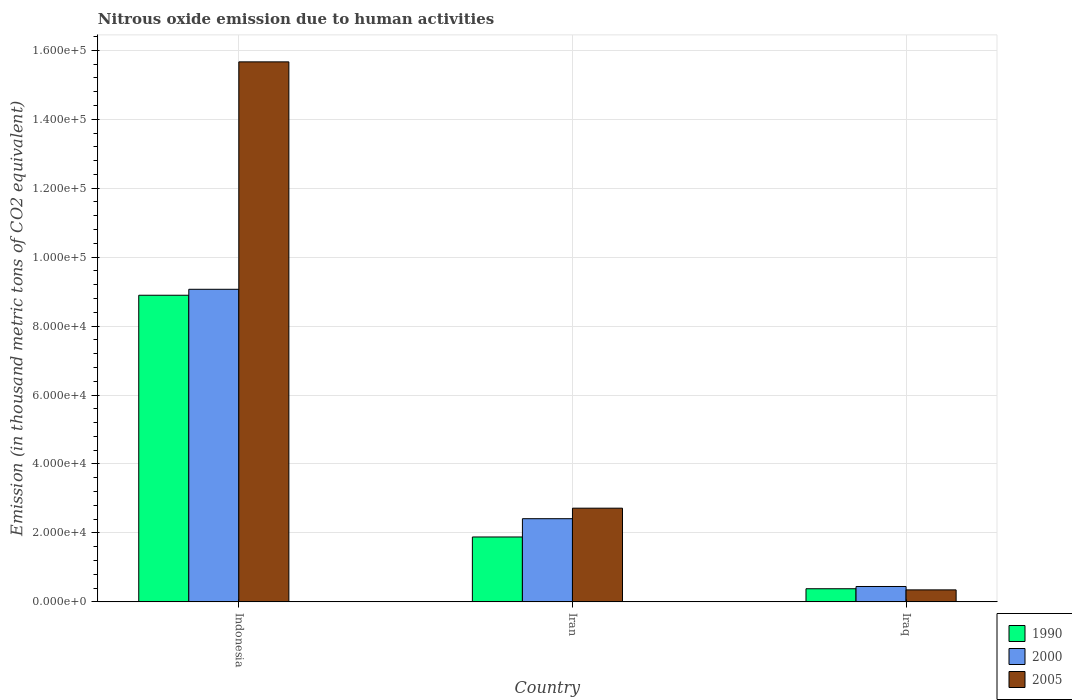Are the number of bars per tick equal to the number of legend labels?
Offer a terse response. Yes. How many bars are there on the 1st tick from the left?
Make the answer very short. 3. What is the label of the 3rd group of bars from the left?
Provide a short and direct response. Iraq. In how many cases, is the number of bars for a given country not equal to the number of legend labels?
Provide a succinct answer. 0. What is the amount of nitrous oxide emitted in 2005 in Indonesia?
Make the answer very short. 1.57e+05. Across all countries, what is the maximum amount of nitrous oxide emitted in 1990?
Your response must be concise. 8.89e+04. Across all countries, what is the minimum amount of nitrous oxide emitted in 2005?
Keep it short and to the point. 3478.3. In which country was the amount of nitrous oxide emitted in 2000 maximum?
Offer a terse response. Indonesia. In which country was the amount of nitrous oxide emitted in 1990 minimum?
Your answer should be very brief. Iraq. What is the total amount of nitrous oxide emitted in 2005 in the graph?
Provide a succinct answer. 1.87e+05. What is the difference between the amount of nitrous oxide emitted in 1990 in Indonesia and that in Iraq?
Make the answer very short. 8.51e+04. What is the difference between the amount of nitrous oxide emitted in 2005 in Iraq and the amount of nitrous oxide emitted in 2000 in Indonesia?
Ensure brevity in your answer.  -8.72e+04. What is the average amount of nitrous oxide emitted in 2000 per country?
Ensure brevity in your answer.  3.98e+04. What is the difference between the amount of nitrous oxide emitted of/in 2005 and amount of nitrous oxide emitted of/in 2000 in Iraq?
Offer a terse response. -984. In how many countries, is the amount of nitrous oxide emitted in 2000 greater than 32000 thousand metric tons?
Your answer should be compact. 1. What is the ratio of the amount of nitrous oxide emitted in 2005 in Indonesia to that in Iraq?
Keep it short and to the point. 45.04. Is the amount of nitrous oxide emitted in 2005 in Indonesia less than that in Iran?
Give a very brief answer. No. What is the difference between the highest and the second highest amount of nitrous oxide emitted in 2005?
Make the answer very short. -1.29e+05. What is the difference between the highest and the lowest amount of nitrous oxide emitted in 2000?
Give a very brief answer. 8.62e+04. Is the sum of the amount of nitrous oxide emitted in 1990 in Indonesia and Iraq greater than the maximum amount of nitrous oxide emitted in 2000 across all countries?
Your answer should be very brief. Yes. What does the 3rd bar from the left in Iraq represents?
Give a very brief answer. 2005. What does the 2nd bar from the right in Iraq represents?
Provide a short and direct response. 2000. Is it the case that in every country, the sum of the amount of nitrous oxide emitted in 1990 and amount of nitrous oxide emitted in 2005 is greater than the amount of nitrous oxide emitted in 2000?
Ensure brevity in your answer.  Yes. How many bars are there?
Your response must be concise. 9. How many countries are there in the graph?
Offer a terse response. 3. Are the values on the major ticks of Y-axis written in scientific E-notation?
Ensure brevity in your answer.  Yes. Does the graph contain any zero values?
Make the answer very short. No. Where does the legend appear in the graph?
Keep it short and to the point. Bottom right. How many legend labels are there?
Keep it short and to the point. 3. What is the title of the graph?
Offer a very short reply. Nitrous oxide emission due to human activities. Does "1979" appear as one of the legend labels in the graph?
Ensure brevity in your answer.  No. What is the label or title of the Y-axis?
Your answer should be compact. Emission (in thousand metric tons of CO2 equivalent). What is the Emission (in thousand metric tons of CO2 equivalent) of 1990 in Indonesia?
Offer a very short reply. 8.89e+04. What is the Emission (in thousand metric tons of CO2 equivalent) in 2000 in Indonesia?
Your response must be concise. 9.07e+04. What is the Emission (in thousand metric tons of CO2 equivalent) of 2005 in Indonesia?
Your answer should be compact. 1.57e+05. What is the Emission (in thousand metric tons of CO2 equivalent) in 1990 in Iran?
Your answer should be compact. 1.88e+04. What is the Emission (in thousand metric tons of CO2 equivalent) in 2000 in Iran?
Give a very brief answer. 2.41e+04. What is the Emission (in thousand metric tons of CO2 equivalent) in 2005 in Iran?
Provide a short and direct response. 2.72e+04. What is the Emission (in thousand metric tons of CO2 equivalent) of 1990 in Iraq?
Offer a very short reply. 3808.9. What is the Emission (in thousand metric tons of CO2 equivalent) in 2000 in Iraq?
Give a very brief answer. 4462.3. What is the Emission (in thousand metric tons of CO2 equivalent) of 2005 in Iraq?
Give a very brief answer. 3478.3. Across all countries, what is the maximum Emission (in thousand metric tons of CO2 equivalent) in 1990?
Offer a terse response. 8.89e+04. Across all countries, what is the maximum Emission (in thousand metric tons of CO2 equivalent) in 2000?
Provide a succinct answer. 9.07e+04. Across all countries, what is the maximum Emission (in thousand metric tons of CO2 equivalent) of 2005?
Ensure brevity in your answer.  1.57e+05. Across all countries, what is the minimum Emission (in thousand metric tons of CO2 equivalent) of 1990?
Your answer should be compact. 3808.9. Across all countries, what is the minimum Emission (in thousand metric tons of CO2 equivalent) in 2000?
Offer a very short reply. 4462.3. Across all countries, what is the minimum Emission (in thousand metric tons of CO2 equivalent) of 2005?
Make the answer very short. 3478.3. What is the total Emission (in thousand metric tons of CO2 equivalent) of 1990 in the graph?
Your answer should be very brief. 1.12e+05. What is the total Emission (in thousand metric tons of CO2 equivalent) of 2000 in the graph?
Offer a terse response. 1.19e+05. What is the total Emission (in thousand metric tons of CO2 equivalent) in 2005 in the graph?
Provide a short and direct response. 1.87e+05. What is the difference between the Emission (in thousand metric tons of CO2 equivalent) of 1990 in Indonesia and that in Iran?
Your response must be concise. 7.01e+04. What is the difference between the Emission (in thousand metric tons of CO2 equivalent) in 2000 in Indonesia and that in Iran?
Give a very brief answer. 6.65e+04. What is the difference between the Emission (in thousand metric tons of CO2 equivalent) in 2005 in Indonesia and that in Iran?
Your answer should be compact. 1.29e+05. What is the difference between the Emission (in thousand metric tons of CO2 equivalent) in 1990 in Indonesia and that in Iraq?
Keep it short and to the point. 8.51e+04. What is the difference between the Emission (in thousand metric tons of CO2 equivalent) in 2000 in Indonesia and that in Iraq?
Your answer should be compact. 8.62e+04. What is the difference between the Emission (in thousand metric tons of CO2 equivalent) of 2005 in Indonesia and that in Iraq?
Provide a short and direct response. 1.53e+05. What is the difference between the Emission (in thousand metric tons of CO2 equivalent) of 1990 in Iran and that in Iraq?
Your response must be concise. 1.50e+04. What is the difference between the Emission (in thousand metric tons of CO2 equivalent) in 2000 in Iran and that in Iraq?
Your response must be concise. 1.97e+04. What is the difference between the Emission (in thousand metric tons of CO2 equivalent) in 2005 in Iran and that in Iraq?
Make the answer very short. 2.37e+04. What is the difference between the Emission (in thousand metric tons of CO2 equivalent) of 1990 in Indonesia and the Emission (in thousand metric tons of CO2 equivalent) of 2000 in Iran?
Make the answer very short. 6.48e+04. What is the difference between the Emission (in thousand metric tons of CO2 equivalent) of 1990 in Indonesia and the Emission (in thousand metric tons of CO2 equivalent) of 2005 in Iran?
Offer a very short reply. 6.18e+04. What is the difference between the Emission (in thousand metric tons of CO2 equivalent) of 2000 in Indonesia and the Emission (in thousand metric tons of CO2 equivalent) of 2005 in Iran?
Keep it short and to the point. 6.35e+04. What is the difference between the Emission (in thousand metric tons of CO2 equivalent) in 1990 in Indonesia and the Emission (in thousand metric tons of CO2 equivalent) in 2000 in Iraq?
Ensure brevity in your answer.  8.45e+04. What is the difference between the Emission (in thousand metric tons of CO2 equivalent) of 1990 in Indonesia and the Emission (in thousand metric tons of CO2 equivalent) of 2005 in Iraq?
Provide a short and direct response. 8.55e+04. What is the difference between the Emission (in thousand metric tons of CO2 equivalent) in 2000 in Indonesia and the Emission (in thousand metric tons of CO2 equivalent) in 2005 in Iraq?
Your response must be concise. 8.72e+04. What is the difference between the Emission (in thousand metric tons of CO2 equivalent) in 1990 in Iran and the Emission (in thousand metric tons of CO2 equivalent) in 2000 in Iraq?
Provide a succinct answer. 1.44e+04. What is the difference between the Emission (in thousand metric tons of CO2 equivalent) of 1990 in Iran and the Emission (in thousand metric tons of CO2 equivalent) of 2005 in Iraq?
Provide a short and direct response. 1.53e+04. What is the difference between the Emission (in thousand metric tons of CO2 equivalent) of 2000 in Iran and the Emission (in thousand metric tons of CO2 equivalent) of 2005 in Iraq?
Offer a very short reply. 2.06e+04. What is the average Emission (in thousand metric tons of CO2 equivalent) of 1990 per country?
Ensure brevity in your answer.  3.72e+04. What is the average Emission (in thousand metric tons of CO2 equivalent) in 2000 per country?
Provide a short and direct response. 3.98e+04. What is the average Emission (in thousand metric tons of CO2 equivalent) in 2005 per country?
Give a very brief answer. 6.24e+04. What is the difference between the Emission (in thousand metric tons of CO2 equivalent) of 1990 and Emission (in thousand metric tons of CO2 equivalent) of 2000 in Indonesia?
Your answer should be compact. -1727.1. What is the difference between the Emission (in thousand metric tons of CO2 equivalent) of 1990 and Emission (in thousand metric tons of CO2 equivalent) of 2005 in Indonesia?
Provide a short and direct response. -6.77e+04. What is the difference between the Emission (in thousand metric tons of CO2 equivalent) in 2000 and Emission (in thousand metric tons of CO2 equivalent) in 2005 in Indonesia?
Give a very brief answer. -6.60e+04. What is the difference between the Emission (in thousand metric tons of CO2 equivalent) of 1990 and Emission (in thousand metric tons of CO2 equivalent) of 2000 in Iran?
Offer a very short reply. -5303. What is the difference between the Emission (in thousand metric tons of CO2 equivalent) of 1990 and Emission (in thousand metric tons of CO2 equivalent) of 2005 in Iran?
Your answer should be very brief. -8355.6. What is the difference between the Emission (in thousand metric tons of CO2 equivalent) in 2000 and Emission (in thousand metric tons of CO2 equivalent) in 2005 in Iran?
Your response must be concise. -3052.6. What is the difference between the Emission (in thousand metric tons of CO2 equivalent) in 1990 and Emission (in thousand metric tons of CO2 equivalent) in 2000 in Iraq?
Provide a short and direct response. -653.4. What is the difference between the Emission (in thousand metric tons of CO2 equivalent) of 1990 and Emission (in thousand metric tons of CO2 equivalent) of 2005 in Iraq?
Your response must be concise. 330.6. What is the difference between the Emission (in thousand metric tons of CO2 equivalent) of 2000 and Emission (in thousand metric tons of CO2 equivalent) of 2005 in Iraq?
Provide a short and direct response. 984. What is the ratio of the Emission (in thousand metric tons of CO2 equivalent) in 1990 in Indonesia to that in Iran?
Provide a short and direct response. 4.73. What is the ratio of the Emission (in thousand metric tons of CO2 equivalent) of 2000 in Indonesia to that in Iran?
Your response must be concise. 3.76. What is the ratio of the Emission (in thousand metric tons of CO2 equivalent) in 2005 in Indonesia to that in Iran?
Provide a succinct answer. 5.76. What is the ratio of the Emission (in thousand metric tons of CO2 equivalent) of 1990 in Indonesia to that in Iraq?
Provide a short and direct response. 23.35. What is the ratio of the Emission (in thousand metric tons of CO2 equivalent) of 2000 in Indonesia to that in Iraq?
Ensure brevity in your answer.  20.32. What is the ratio of the Emission (in thousand metric tons of CO2 equivalent) in 2005 in Indonesia to that in Iraq?
Provide a succinct answer. 45.03. What is the ratio of the Emission (in thousand metric tons of CO2 equivalent) of 1990 in Iran to that in Iraq?
Offer a very short reply. 4.94. What is the ratio of the Emission (in thousand metric tons of CO2 equivalent) in 2000 in Iran to that in Iraq?
Keep it short and to the point. 5.41. What is the ratio of the Emission (in thousand metric tons of CO2 equivalent) in 2005 in Iran to that in Iraq?
Your answer should be very brief. 7.81. What is the difference between the highest and the second highest Emission (in thousand metric tons of CO2 equivalent) of 1990?
Your response must be concise. 7.01e+04. What is the difference between the highest and the second highest Emission (in thousand metric tons of CO2 equivalent) of 2000?
Provide a succinct answer. 6.65e+04. What is the difference between the highest and the second highest Emission (in thousand metric tons of CO2 equivalent) in 2005?
Offer a terse response. 1.29e+05. What is the difference between the highest and the lowest Emission (in thousand metric tons of CO2 equivalent) in 1990?
Offer a very short reply. 8.51e+04. What is the difference between the highest and the lowest Emission (in thousand metric tons of CO2 equivalent) in 2000?
Offer a terse response. 8.62e+04. What is the difference between the highest and the lowest Emission (in thousand metric tons of CO2 equivalent) of 2005?
Provide a short and direct response. 1.53e+05. 